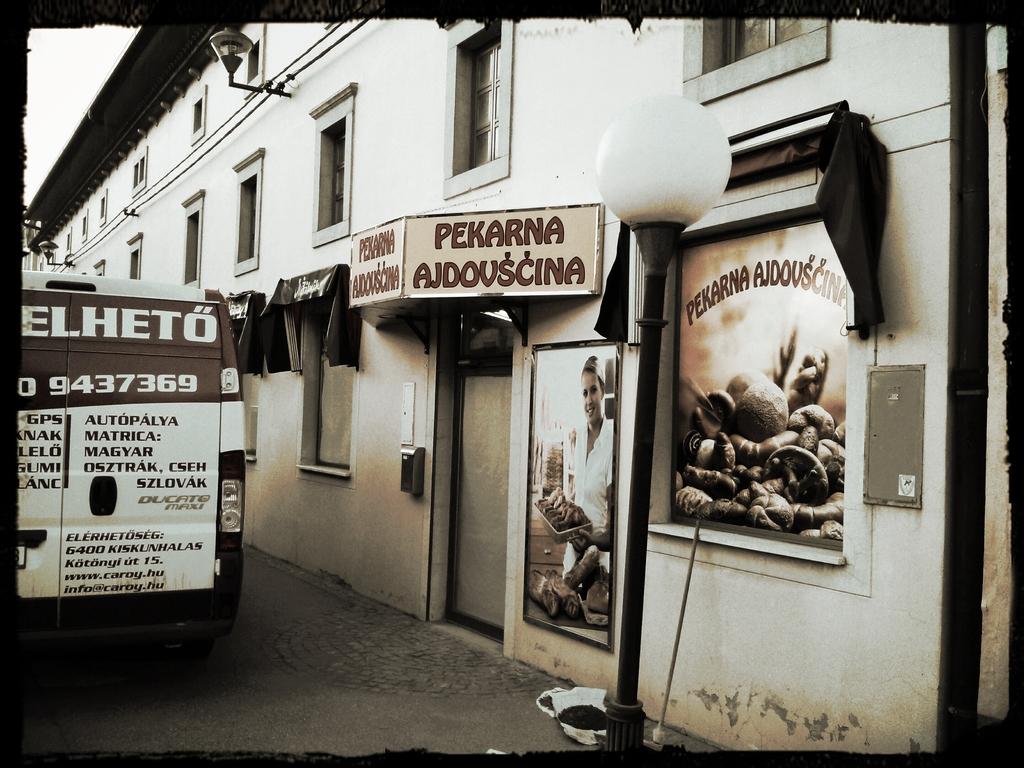What is the number on the back of the bus?
Your answer should be compact. 9437369. 